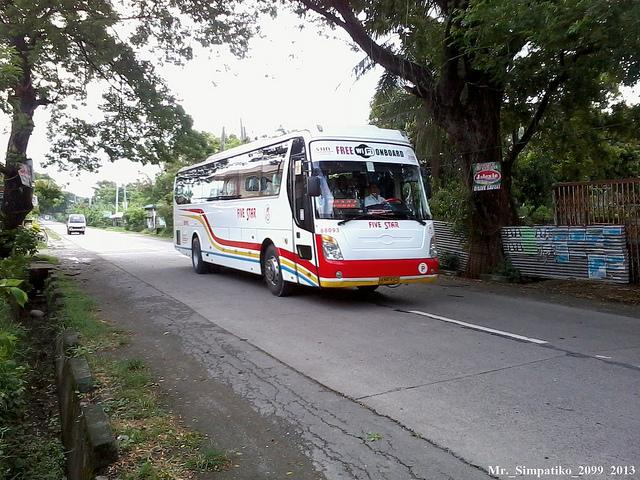What complimentary service does the bus offer on board? wifi 